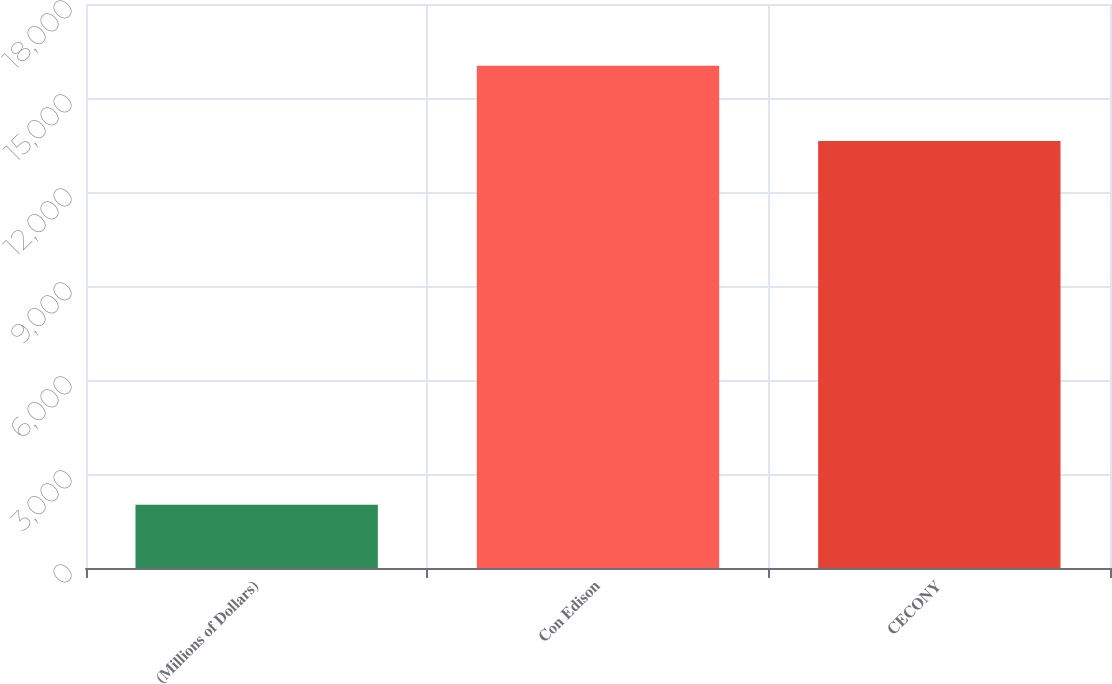<chart> <loc_0><loc_0><loc_500><loc_500><bar_chart><fcel>(Millions of Dollars)<fcel>Con Edison<fcel>CECONY<nl><fcel>2017<fcel>16029<fcel>13625<nl></chart> 